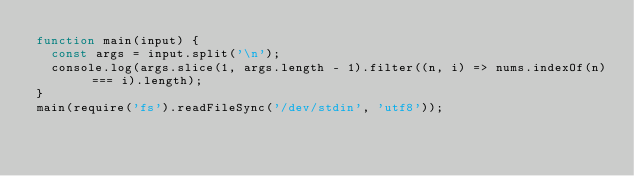<code> <loc_0><loc_0><loc_500><loc_500><_JavaScript_>function main(input) {
  const args = input.split('\n');
  console.log(args.slice(1, args.length - 1).filter((n, i) => nums.indexOf(n) === i).length);
}
main(require('fs').readFileSync('/dev/stdin', 'utf8'));</code> 